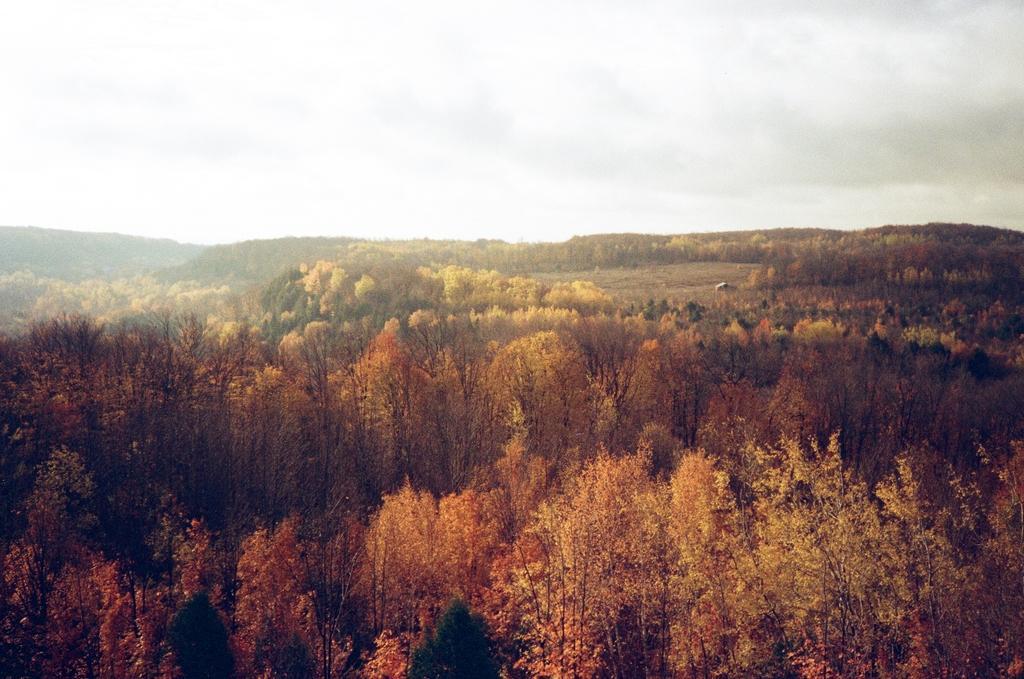Describe this image in one or two sentences. This is an aerial view. In this picture we can see the hills and trees. At the top of the image we can see the clouds are present in the sky. 